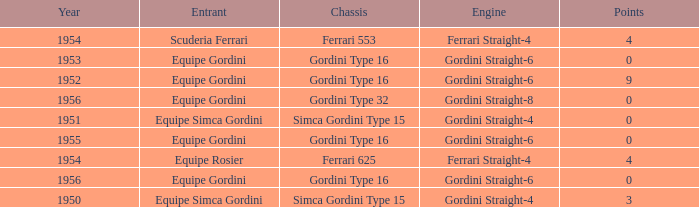How many points after 1956? 0.0. 